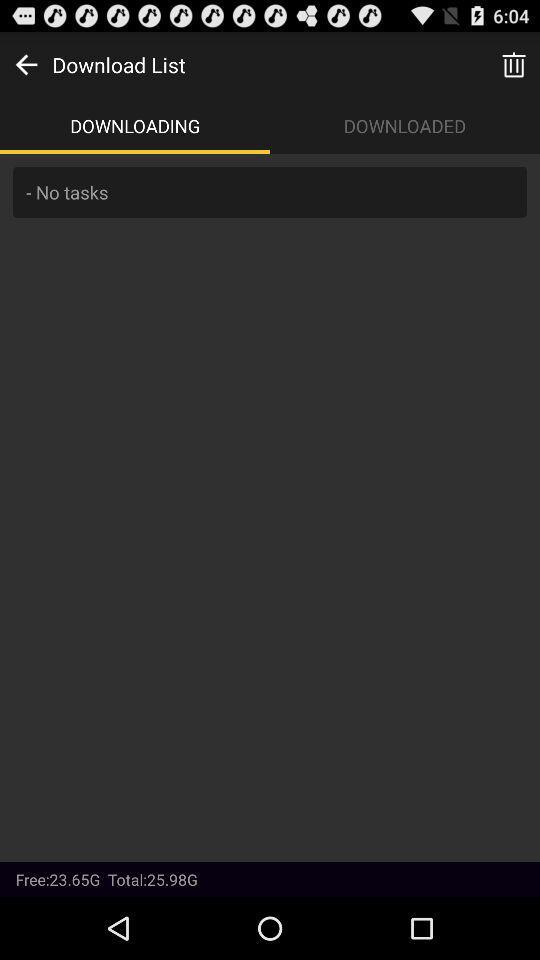Which tab is selected? The selected tab is "DOWNLOADING". 